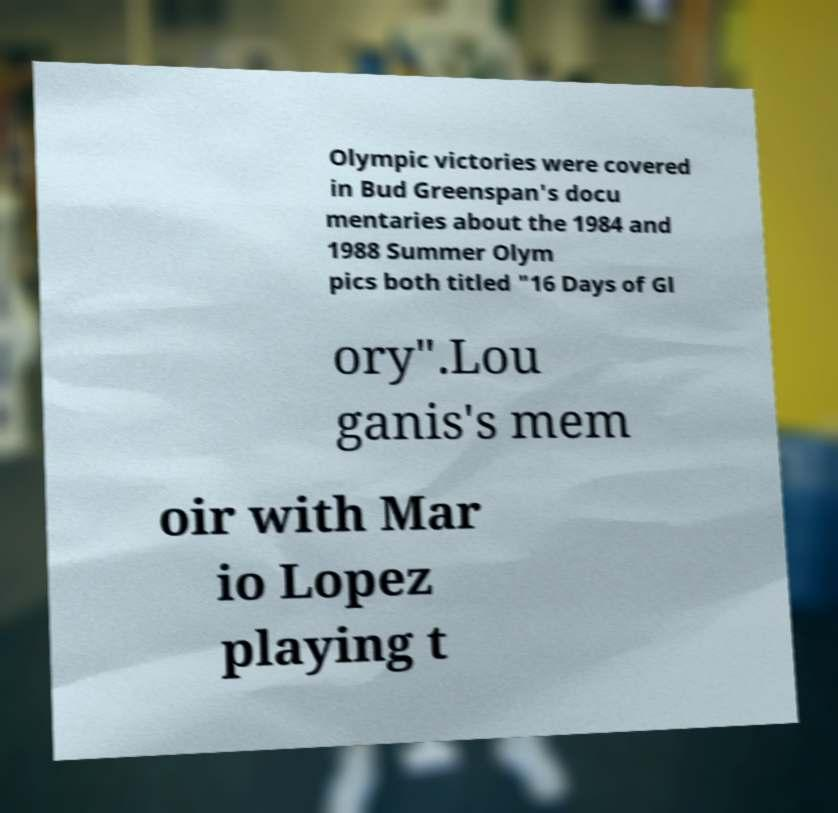Could you extract and type out the text from this image? Olympic victories were covered in Bud Greenspan's docu mentaries about the 1984 and 1988 Summer Olym pics both titled "16 Days of Gl ory".Lou ganis's mem oir with Mar io Lopez playing t 